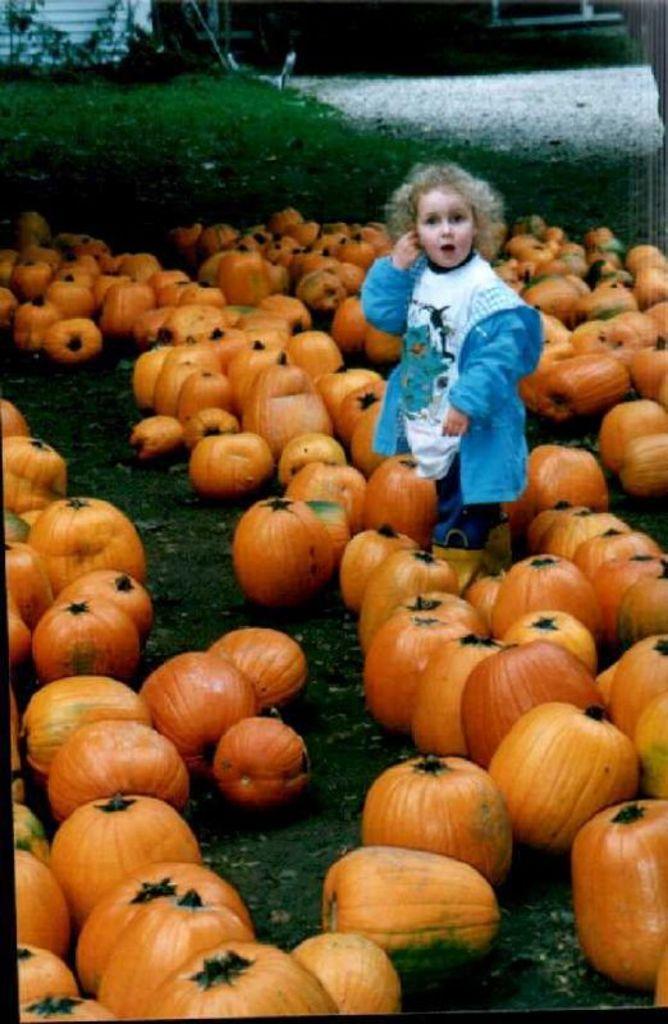How would you summarize this image in a sentence or two? In the picture there is a girl standing in between the pumpkins and the pumpkins were kept on the grass. 